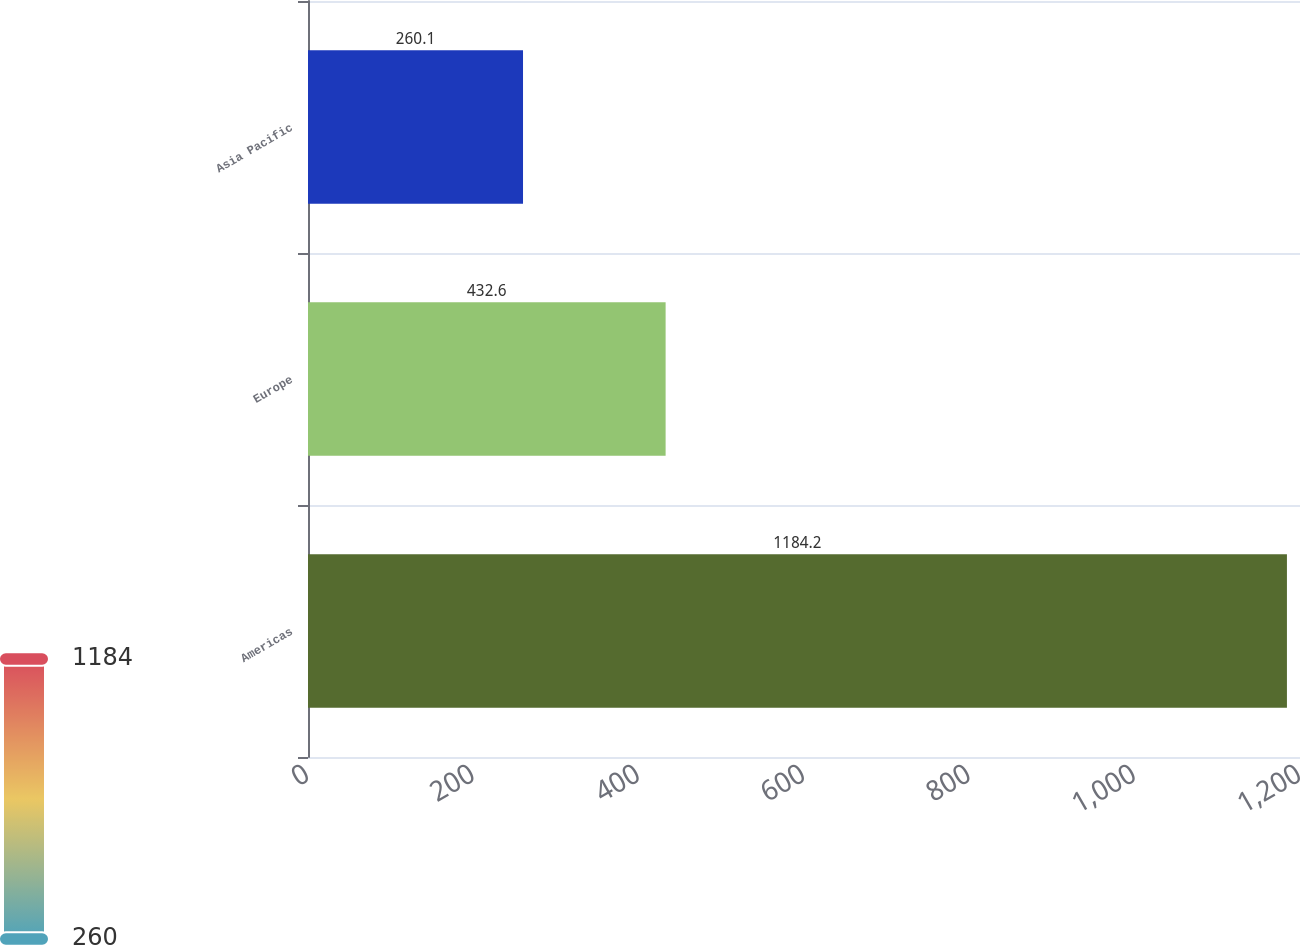Convert chart. <chart><loc_0><loc_0><loc_500><loc_500><bar_chart><fcel>Americas<fcel>Europe<fcel>Asia Pacific<nl><fcel>1184.2<fcel>432.6<fcel>260.1<nl></chart> 